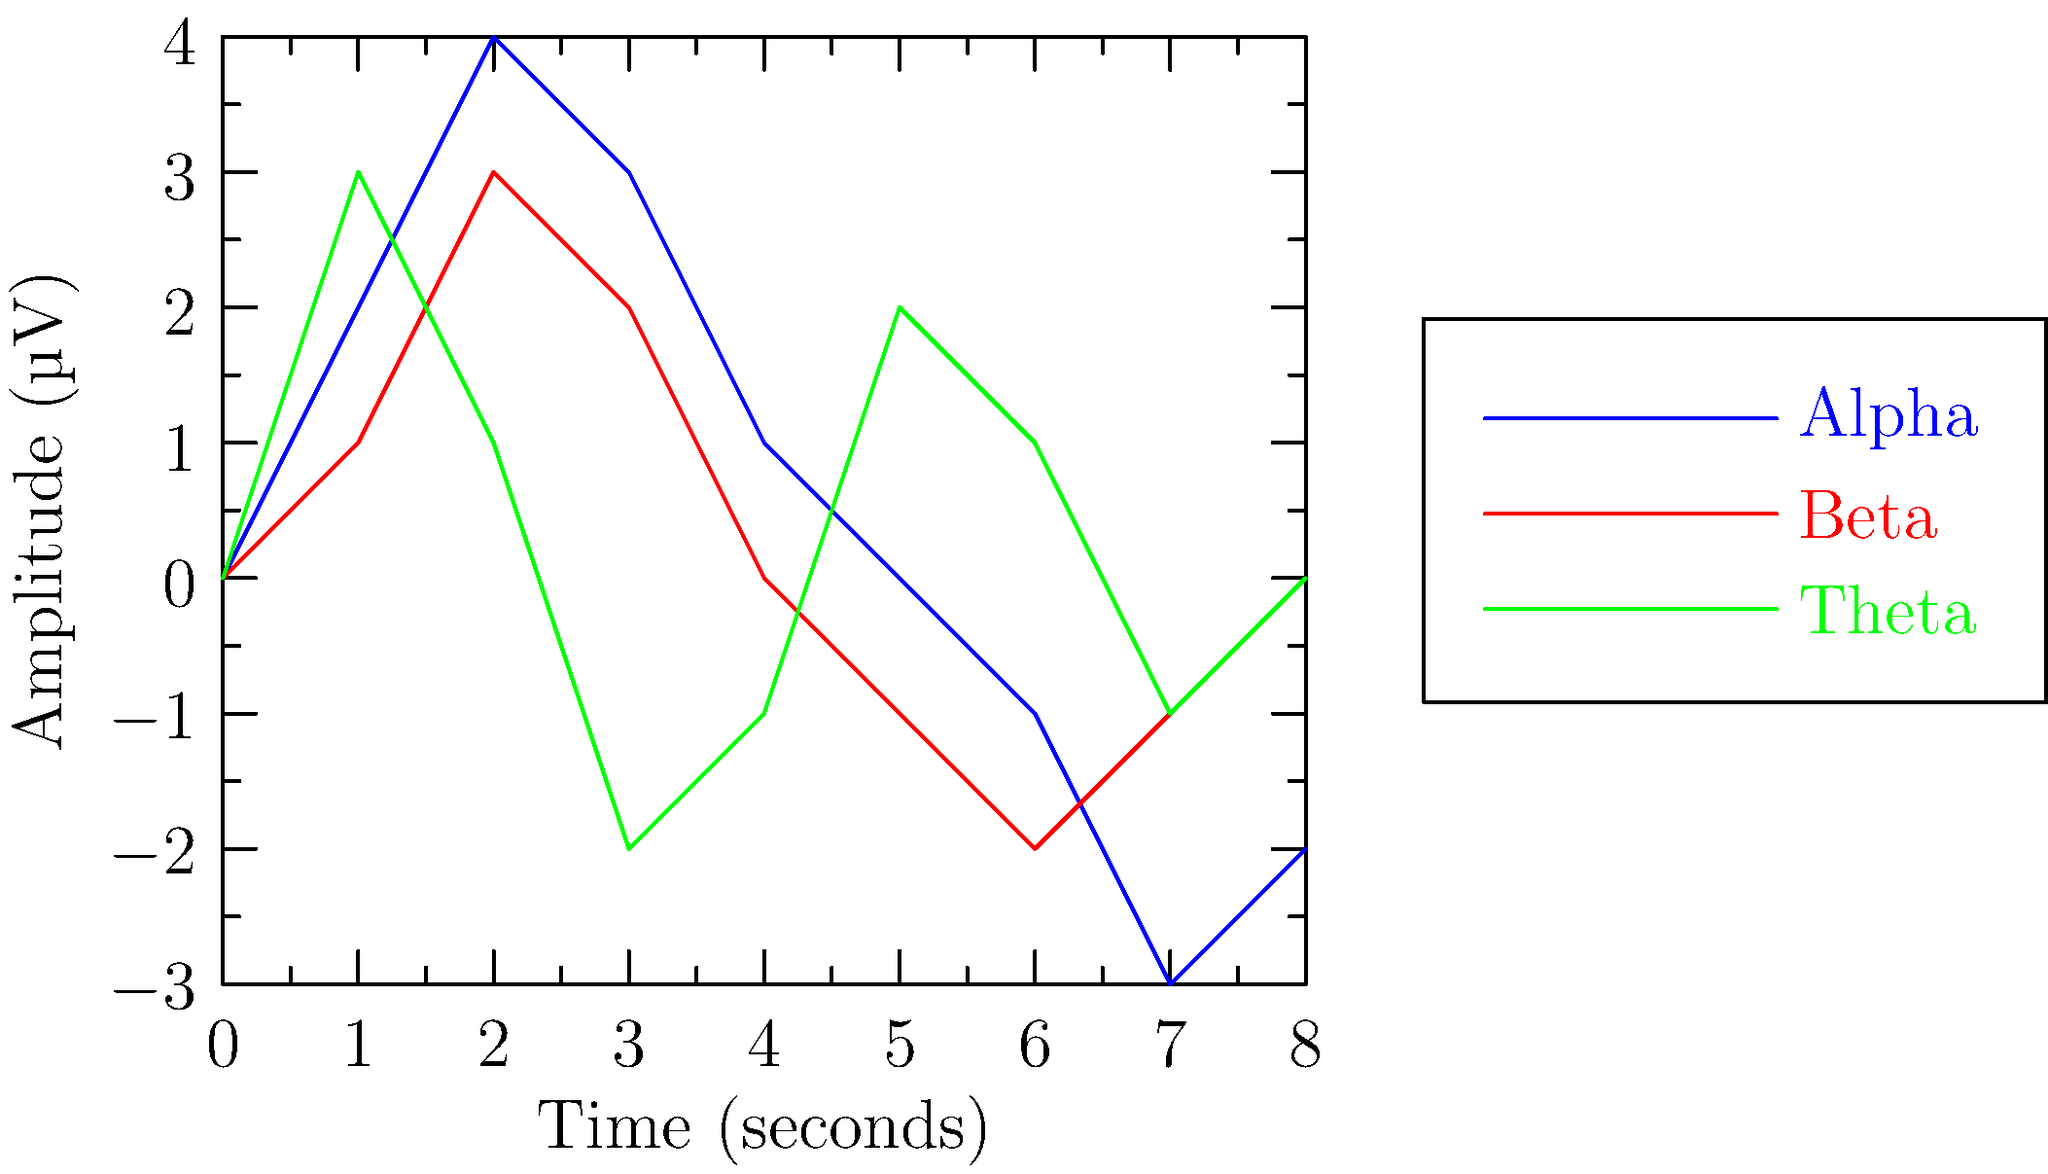Analyze the EEG graph above, which shows three different brain wave patterns over an 8-second period. Which wave pattern exhibits the highest frequency, and what cognitive state does it likely represent? To answer this question, let's analyze the graph step-by-step:

1. Identify the three wave patterns:
   - Blue line: Alpha waves
   - Red line: Beta waves
   - Green line: Theta waves

2. Compare the frequencies:
   - Alpha waves: About 1-2 cycles per second
   - Beta waves: About 2-3 cycles per second
   - Theta waves: About 1 cycle per second

3. Determine the highest frequency:
   The red line (Beta waves) shows the highest frequency among the three patterns.

4. Cognitive state represented by Beta waves:
   Beta waves are associated with active, alert mental states, including:
   - Focused attention
   - Problem-solving
   - Critical thinking
   - Active engagement in cognitive tasks

5. Relevance to the persona:
   As a neurosurgeon, understanding EEG patterns is crucial for diagnosing and treating neurological conditions. Beta waves are particularly important in assessing a patient's level of consciousness and cognitive function during and after surgical procedures.
Answer: Beta waves; alert and focused mental state 